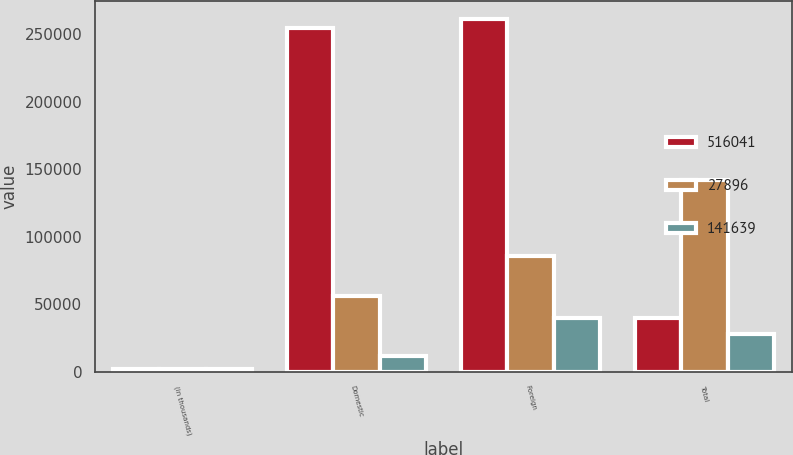<chart> <loc_0><loc_0><loc_500><loc_500><stacked_bar_chart><ecel><fcel>(in thousands)<fcel>Domestic<fcel>Foreign<fcel>Total<nl><fcel>516041<fcel>2004<fcel>254582<fcel>261459<fcel>39532<nl><fcel>27896<fcel>2003<fcel>56068<fcel>85571<fcel>141639<nl><fcel>141639<fcel>2002<fcel>11636<fcel>39532<fcel>27896<nl></chart> 